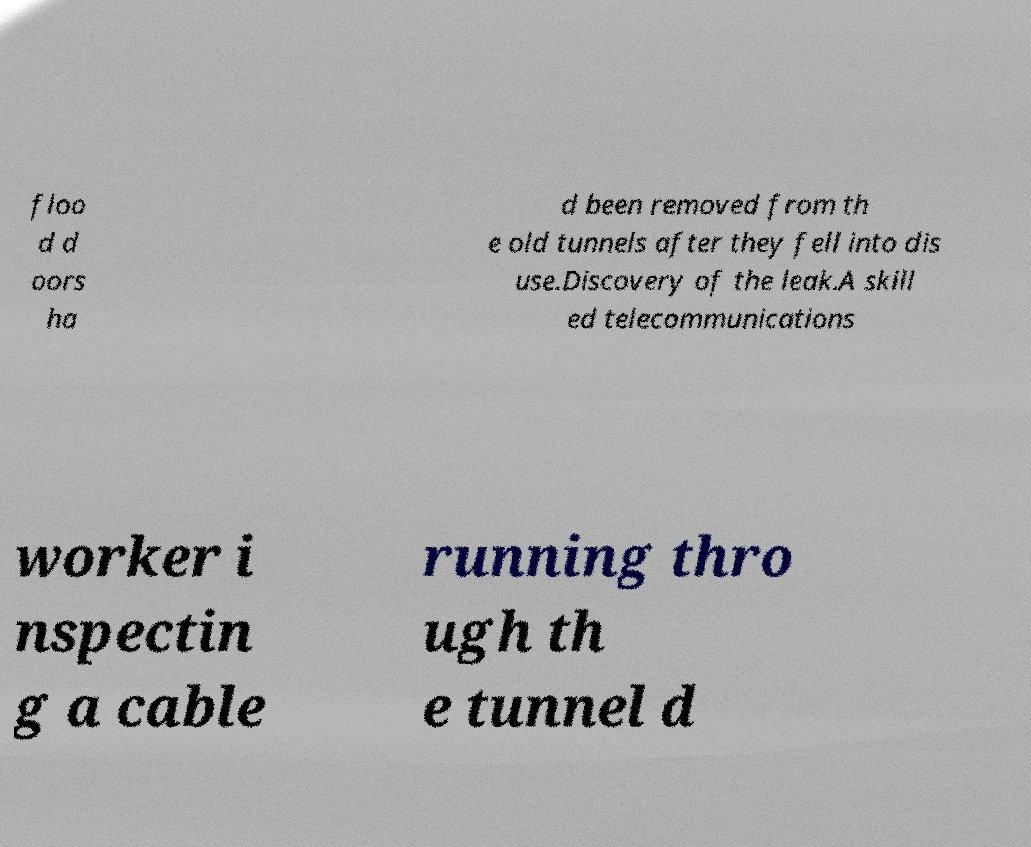Could you extract and type out the text from this image? floo d d oors ha d been removed from th e old tunnels after they fell into dis use.Discovery of the leak.A skill ed telecommunications worker i nspectin g a cable running thro ugh th e tunnel d 